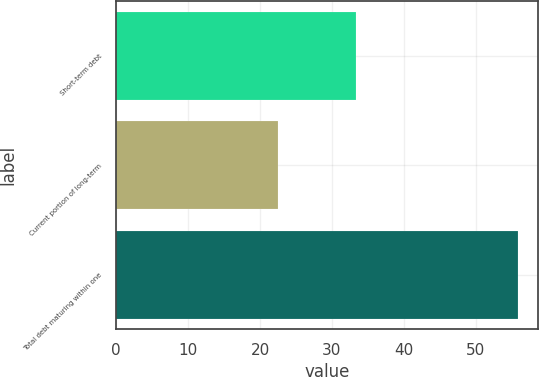Convert chart to OTSL. <chart><loc_0><loc_0><loc_500><loc_500><bar_chart><fcel>Short-term debt<fcel>Current portion of long-term<fcel>Total debt maturing within one<nl><fcel>33.4<fcel>22.5<fcel>55.9<nl></chart> 